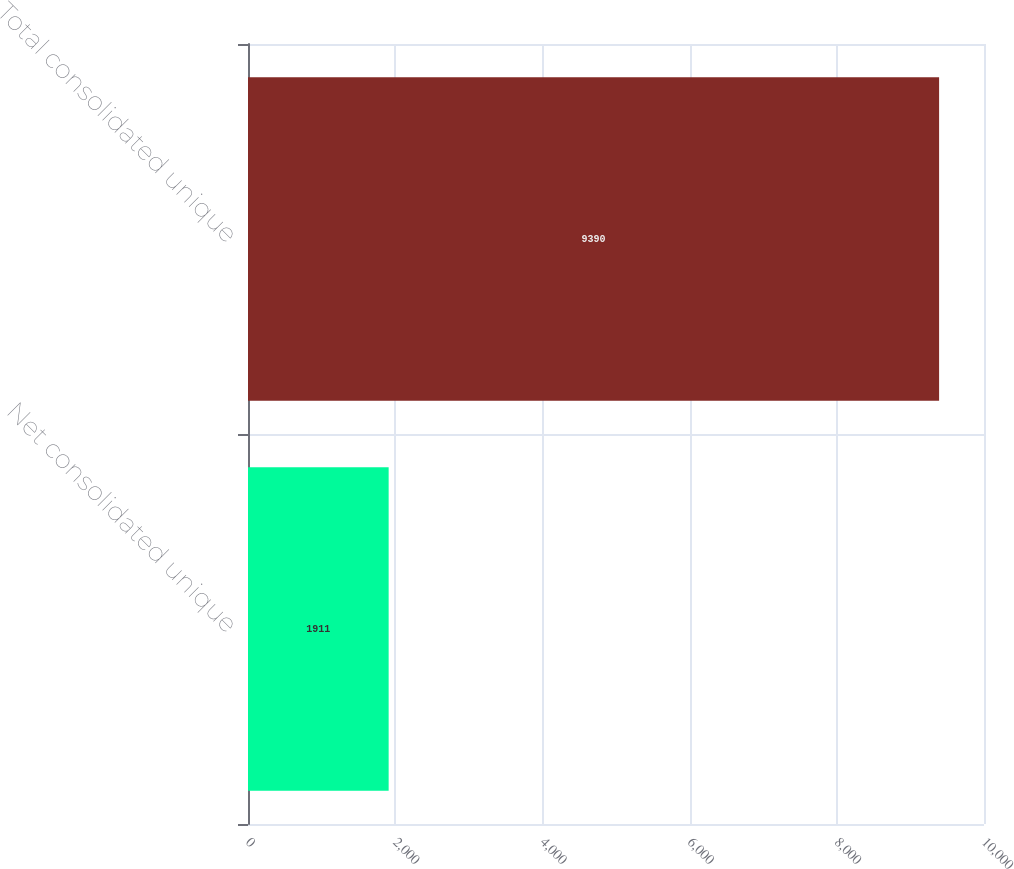Convert chart to OTSL. <chart><loc_0><loc_0><loc_500><loc_500><bar_chart><fcel>Net consolidated unique<fcel>Total consolidated unique<nl><fcel>1911<fcel>9390<nl></chart> 